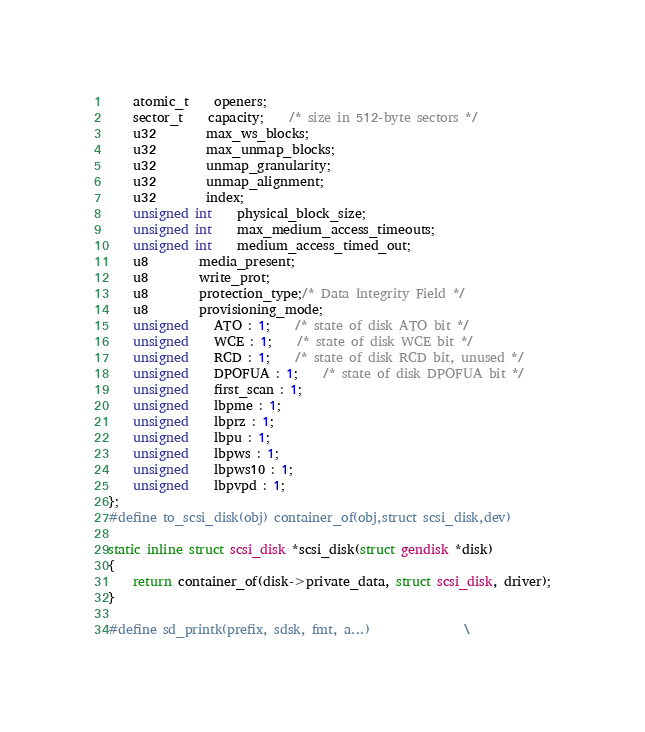Convert code to text. <code><loc_0><loc_0><loc_500><loc_500><_C_>	atomic_t	openers;
	sector_t	capacity;	/* size in 512-byte sectors */
	u32		max_ws_blocks;
	u32		max_unmap_blocks;
	u32		unmap_granularity;
	u32		unmap_alignment;
	u32		index;
	unsigned int	physical_block_size;
	unsigned int	max_medium_access_timeouts;
	unsigned int	medium_access_timed_out;
	u8		media_present;
	u8		write_prot;
	u8		protection_type;/* Data Integrity Field */
	u8		provisioning_mode;
	unsigned	ATO : 1;	/* state of disk ATO bit */
	unsigned	WCE : 1;	/* state of disk WCE bit */
	unsigned	RCD : 1;	/* state of disk RCD bit, unused */
	unsigned	DPOFUA : 1;	/* state of disk DPOFUA bit */
	unsigned	first_scan : 1;
	unsigned	lbpme : 1;
	unsigned	lbprz : 1;
	unsigned	lbpu : 1;
	unsigned	lbpws : 1;
	unsigned	lbpws10 : 1;
	unsigned	lbpvpd : 1;
};
#define to_scsi_disk(obj) container_of(obj,struct scsi_disk,dev)

static inline struct scsi_disk *scsi_disk(struct gendisk *disk)
{
	return container_of(disk->private_data, struct scsi_disk, driver);
}

#define sd_printk(prefix, sdsk, fmt, a...)				\</code> 